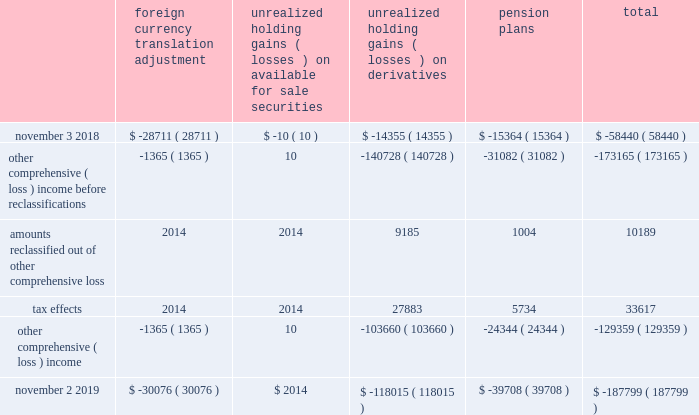Expected durations of less than one year .
The company generally offers a twelve-month warranty for its products .
The company 2019s warranty policy provides for replacement of defective products .
Specific accruals are recorded forff known product warranty issues .
Transaction price : the transaction price reflects the company 2019s expectations about the consideration it will be entitled to receive from the customer and may include fixed or variable amounts .
Fixed consideration primarily includes sales to direct customers and sales to distributors in which both the sale to the distributor and the sale to the end customer occur within the same reporting period .
Variable consideration includes sales in which the amount of consideration that the company will receive is unknown as of the end of a reporting period .
Such consideration primarily includes credits issued to the distributor due to price protection and sales made to distributors under agreements that allow certain rights of return , referred to as stock rotation .
Price protection represents price discounts granted to certain distributors to allow the distributor to earn an appropriate margin on sales negotiated with certain customers and in the event of a price decrease subsequent to the date the product was shipped and billed to the distributor .
Stock rotation allows distributors limited levels of returns in order to reduce the amounts of slow-moving , discontinued or obsolete product from their inventory .
A liability for distributor credits covering variable consideration is made based on the company's estimate of historical experience rates as well as considering economic conditions and contractual terms .
To date , actual distributor claims activity has been materially consistent with the provisions the company has made based on its historical estimates .
For the years ended november 2 , 2019 and november 3 , 2018 , sales to distributors were $ 3.4 billion in both periods , net of variable consideration for which the liability balances as of november 2 , 2019 and november 3 , 2018 were $ 227.0 million and $ 144.9 million , respectively .
Contract balances : accounts receivable represents the company 2019s unconditional right to receive consideration from its customers .
Payments are typically due within 30 to 45 days of invoicing and do not include a significant financing component .
To date , there have been no material impairment losses on accounts receivable .
There were no material contract assets or contract liabilities recorded on the consolidated balance sheets in any of the periods presented .
The company generally warrants that products will meet their published specifications and that the company will repair or replace defective products for twelve-months from the date title passes to the customer .
Specific accruals are recorded for known product warranty issues .
Product warranty expenses during fiscal 2019 , fiscal 2018 and fiscal 2017 were not material .
Accumulated other compcc rehensive ( loss ) income accumulated other comprehensive ( loss ) income ( aoci ) includes certain transactions that have generally been reported in the consolidated statement of shareholders 2019 equity .
The components of aoci at november 2 , 2019 and november 3 , 2018 consisted of the following , net of tax : foreign currency translation adjustment unrealized holding gains ( losses ) on available for sale securities unrealized holding ( losses ) on derivatives pension plans total .
November 2 , 2019 $ ( 30076 ) $ 2014 $ ( 118015 ) $ ( 39708 ) $ ( 187799 ) ( ) ( ) ( ) ( ) ( ) ( ) ( ) ( ) analog devices , inc .
Notes to consolidated financial statements 2014 ( continued ) .
How much did the balance debt increase from 2018 to 2019? 
Rationale: to find how much the balance debt increased over the period of time one has to subtract the 2019 balance by the 2018 balance . then take the answer and divide by the 2018 balance .
Computations: ((187799 - 58440) / 58440)
Answer: 2.21354. 